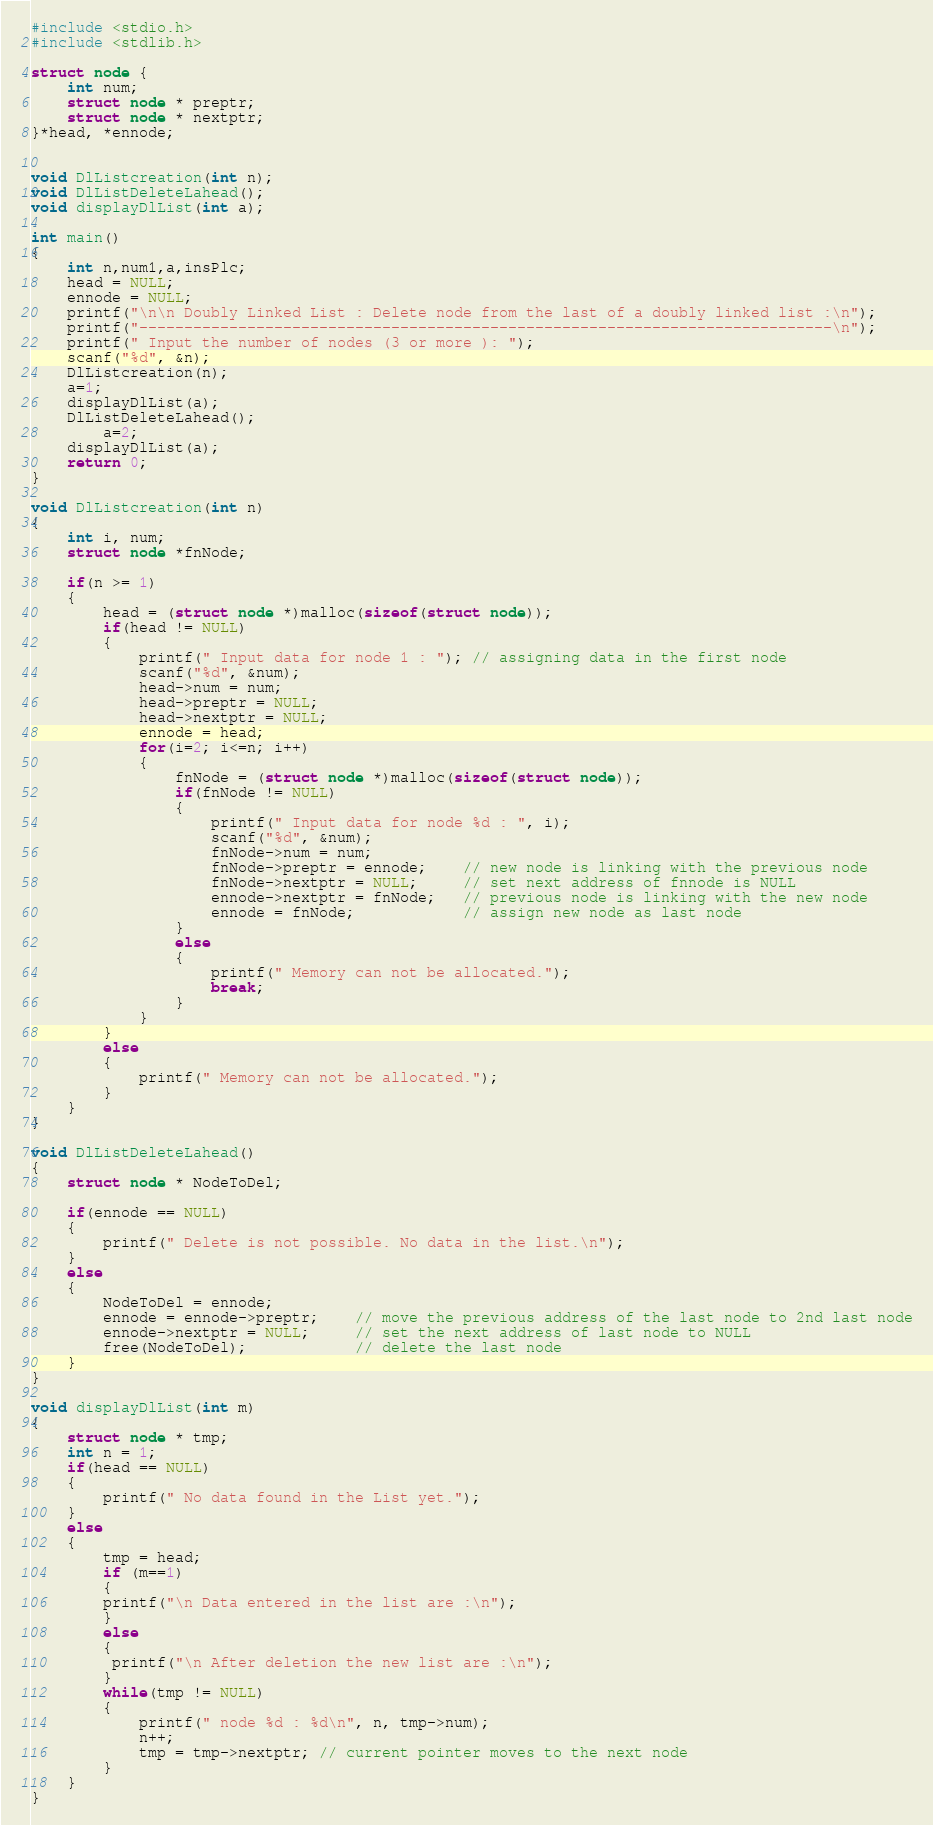<code> <loc_0><loc_0><loc_500><loc_500><_C++_>#include <stdio.h>
#include <stdlib.h>

struct node {
    int num;
    struct node * preptr;
    struct node * nextptr;
}*head, *ennode;


void DlListcreation(int n);
void DlListDeleteLahead();
void displayDlList(int a);

int main()
{
    int n,num1,a,insPlc;
    head = NULL;
    ennode = NULL;
	printf("\n\n Doubly Linked List : Delete node from the last of a doubly linked list :\n");
	printf("-----------------------------------------------------------------------------\n");
    printf(" Input the number of nodes (3 or more ): ");
    scanf("%d", &n);
    DlListcreation(n);
    a=1;
    displayDlList(a);
    DlListDeleteLahead();
        a=2;
    displayDlList(a);
    return 0;
}

void DlListcreation(int n)
{
    int i, num;
    struct node *fnNode;

    if(n >= 1)
    {
        head = (struct node *)malloc(sizeof(struct node));
        if(head != NULL)
        {
            printf(" Input data for node 1 : "); // assigning data in the first node
            scanf("%d", &num);
            head->num = num;
            head->preptr = NULL;
            head->nextptr = NULL;
            ennode = head;
            for(i=2; i<=n; i++)
            {
                fnNode = (struct node *)malloc(sizeof(struct node));
                if(fnNode != NULL)
                {
                    printf(" Input data for node %d : ", i);
                    scanf("%d", &num);
                    fnNode->num = num;
                    fnNode->preptr = ennode;    // new node is linking with the previous node
                    fnNode->nextptr = NULL;     // set next address of fnnode is NULL
                    ennode->nextptr = fnNode;   // previous node is linking with the new node
                    ennode = fnNode;            // assign new node as last node
                }
                else
                {
                    printf(" Memory can not be allocated.");
                    break;
                }
            }
        }
        else
        {
            printf(" Memory can not be allocated.");
        }
    }
}

void DlListDeleteLahead()
{
    struct node * NodeToDel;

    if(ennode == NULL)
    {
        printf(" Delete is not possible. No data in the list.\n");
    }
    else
    {
        NodeToDel = ennode;
        ennode = ennode->preptr;    // move the previous address of the last node to 2nd last node
        ennode->nextptr = NULL;     // set the next address of last node to NULL
        free(NodeToDel);            // delete the last node
    }
}

void displayDlList(int m)
{
    struct node * tmp;
    int n = 1;
    if(head == NULL)
    {
        printf(" No data found in the List yet.");
    }
    else
    {
        tmp = head;
        if (m==1)
        {
        printf("\n Data entered in the list are :\n");
        }
        else
        {
         printf("\n After deletion the new list are :\n");
        }
        while(tmp != NULL)
        {
            printf(" node %d : %d\n", n, tmp->num);
            n++;
            tmp = tmp->nextptr; // current pointer moves to the next node
        }
    }
}
</code> 